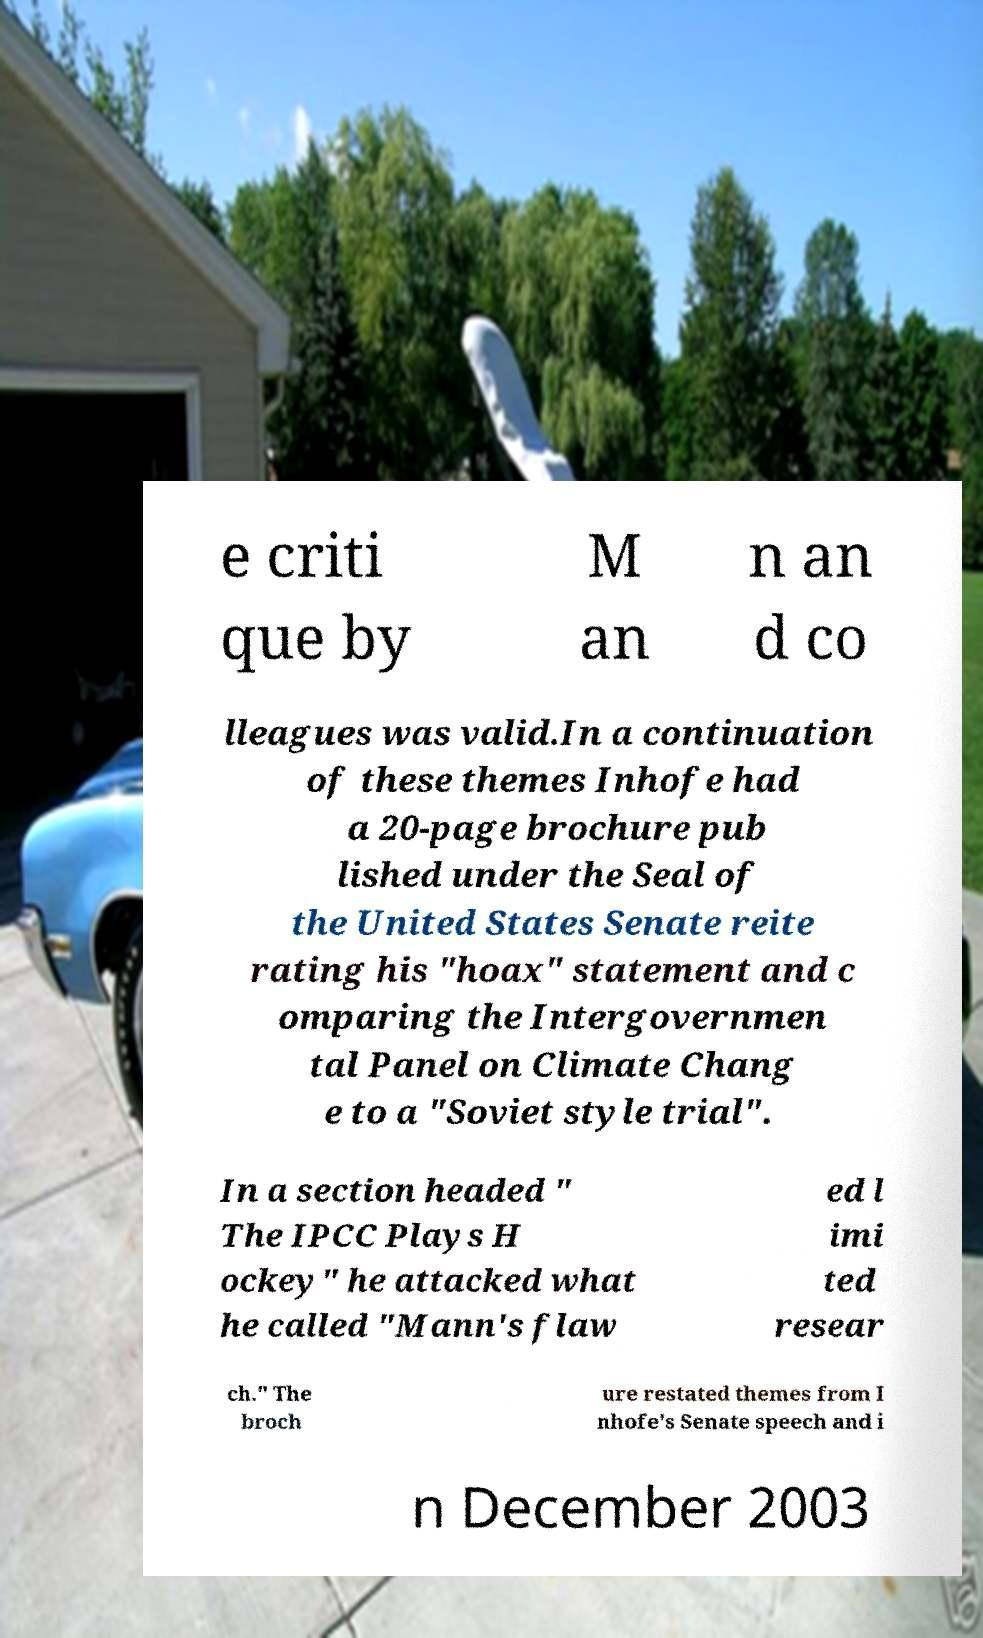I need the written content from this picture converted into text. Can you do that? e criti que by M an n an d co lleagues was valid.In a continuation of these themes Inhofe had a 20-page brochure pub lished under the Seal of the United States Senate reite rating his "hoax" statement and c omparing the Intergovernmen tal Panel on Climate Chang e to a "Soviet style trial". In a section headed " The IPCC Plays H ockey" he attacked what he called "Mann's flaw ed l imi ted resear ch." The broch ure restated themes from I nhofe's Senate speech and i n December 2003 